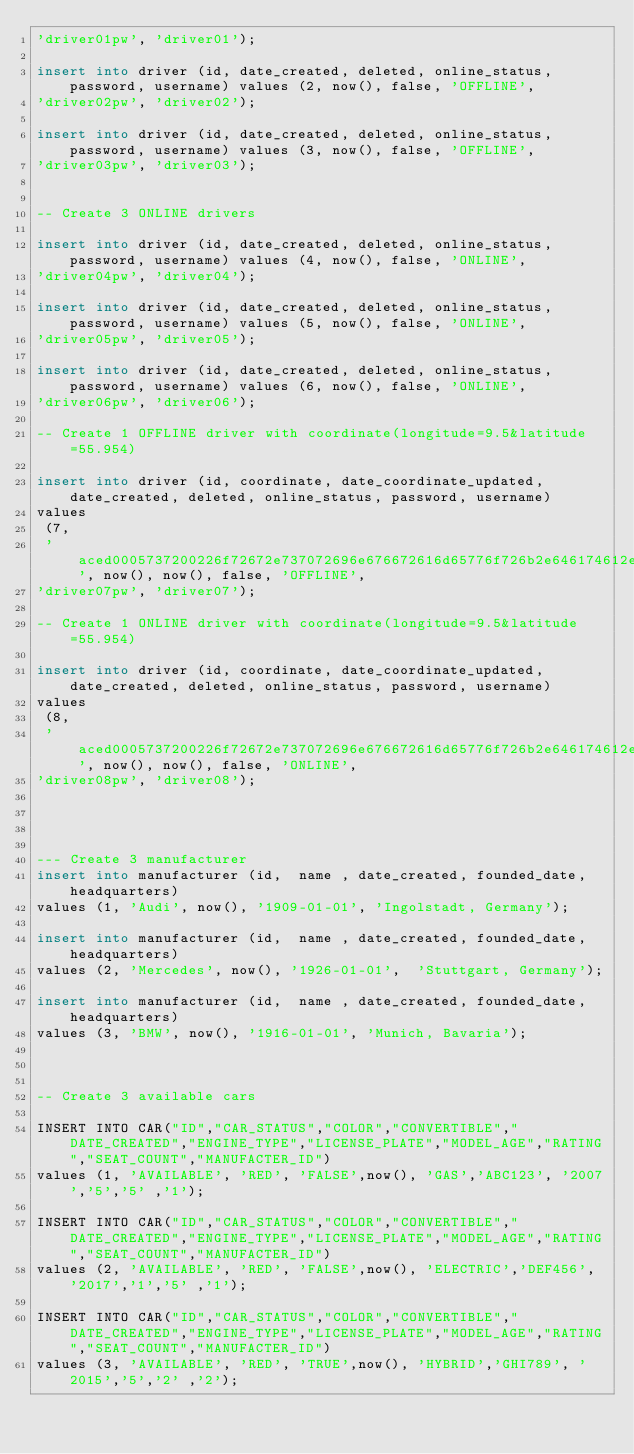Convert code to text. <code><loc_0><loc_0><loc_500><loc_500><_SQL_>'driver01pw', 'driver01');

insert into driver (id, date_created, deleted, online_status, password, username) values (2, now(), false, 'OFFLINE',
'driver02pw', 'driver02');

insert into driver (id, date_created, deleted, online_status, password, username) values (3, now(), false, 'OFFLINE',
'driver03pw', 'driver03');


-- Create 3 ONLINE drivers

insert into driver (id, date_created, deleted, online_status, password, username) values (4, now(), false, 'ONLINE',
'driver04pw', 'driver04');

insert into driver (id, date_created, deleted, online_status, password, username) values (5, now(), false, 'ONLINE',
'driver05pw', 'driver05');

insert into driver (id, date_created, deleted, online_status, password, username) values (6, now(), false, 'ONLINE',
'driver06pw', 'driver06');

-- Create 1 OFFLINE driver with coordinate(longitude=9.5&latitude=55.954)

insert into driver (id, coordinate, date_coordinate_updated, date_created, deleted, online_status, password, username)
values
 (7,
 'aced0005737200226f72672e737072696e676672616d65776f726b2e646174612e67656f2e506f696e7431b9e90ef11a4006020002440001784400017978704023000000000000404bfa1cac083127', now(), now(), false, 'OFFLINE',
'driver07pw', 'driver07');

-- Create 1 ONLINE driver with coordinate(longitude=9.5&latitude=55.954)

insert into driver (id, coordinate, date_coordinate_updated, date_created, deleted, online_status, password, username)
values
 (8,
 'aced0005737200226f72672e737072696e676672616d65776f726b2e646174612e67656f2e506f696e7431b9e90ef11a4006020002440001784400017978704023000000000000404bfa1cac083127', now(), now(), false, 'ONLINE',
'driver08pw', 'driver08');




--- Create 3 manufacturer
insert into manufacturer (id,  name , date_created, founded_date, headquarters)
values (1, 'Audi', now(), '1909-01-01', 'Ingolstadt, Germany');

insert into manufacturer (id,  name , date_created, founded_date, headquarters)
values (2, 'Mercedes', now(), '1926-01-01',  'Stuttgart, Germany');

insert into manufacturer (id,  name , date_created, founded_date, headquarters)
values (3, 'BMW', now(), '1916-01-01', 'Munich, Bavaria');



-- Create 3 available cars

INSERT INTO CAR("ID","CAR_STATUS","COLOR","CONVERTIBLE","DATE_CREATED","ENGINE_TYPE","LICENSE_PLATE","MODEL_AGE","RATING","SEAT_COUNT","MANUFACTER_ID")
values (1, 'AVAILABLE', 'RED', 'FALSE',now(), 'GAS','ABC123', '2007','5','5' ,'1');

INSERT INTO CAR("ID","CAR_STATUS","COLOR","CONVERTIBLE","DATE_CREATED","ENGINE_TYPE","LICENSE_PLATE","MODEL_AGE","RATING","SEAT_COUNT","MANUFACTER_ID")
values (2, 'AVAILABLE', 'RED', 'FALSE',now(), 'ELECTRIC','DEF456', '2017','1','5' ,'1');

INSERT INTO CAR("ID","CAR_STATUS","COLOR","CONVERTIBLE","DATE_CREATED","ENGINE_TYPE","LICENSE_PLATE","MODEL_AGE","RATING","SEAT_COUNT","MANUFACTER_ID")
values (3, 'AVAILABLE', 'RED', 'TRUE',now(), 'HYBRID','GHI789', '2015','5','2' ,'2');


</code> 